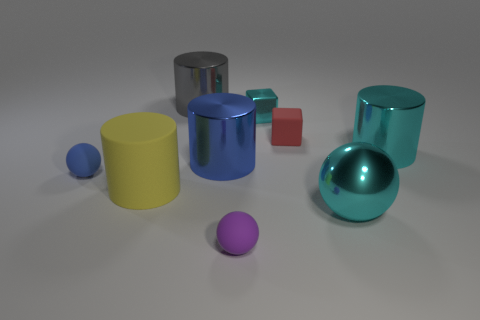How many other objects are there of the same material as the large gray cylinder?
Give a very brief answer. 4. Do the red rubber thing and the large gray thing have the same shape?
Give a very brief answer. No. What size is the matte object in front of the large cyan shiny ball?
Keep it short and to the point. Small. Does the gray metal thing have the same size as the rubber sphere left of the purple thing?
Make the answer very short. No. Are there fewer purple things on the right side of the tiny red matte block than gray things?
Ensure brevity in your answer.  Yes. What material is the cyan thing that is the same shape as the purple matte object?
Offer a very short reply. Metal. There is a tiny matte thing that is on the right side of the rubber cylinder and on the left side of the tiny red cube; what shape is it?
Offer a very short reply. Sphere. There is a large cyan thing that is the same material as the big cyan cylinder; what shape is it?
Keep it short and to the point. Sphere. There is a big cylinder behind the cyan metal cylinder; what is it made of?
Offer a very short reply. Metal. There is a gray thing that is behind the red object; is its size the same as the cylinder in front of the large blue cylinder?
Give a very brief answer. Yes. 